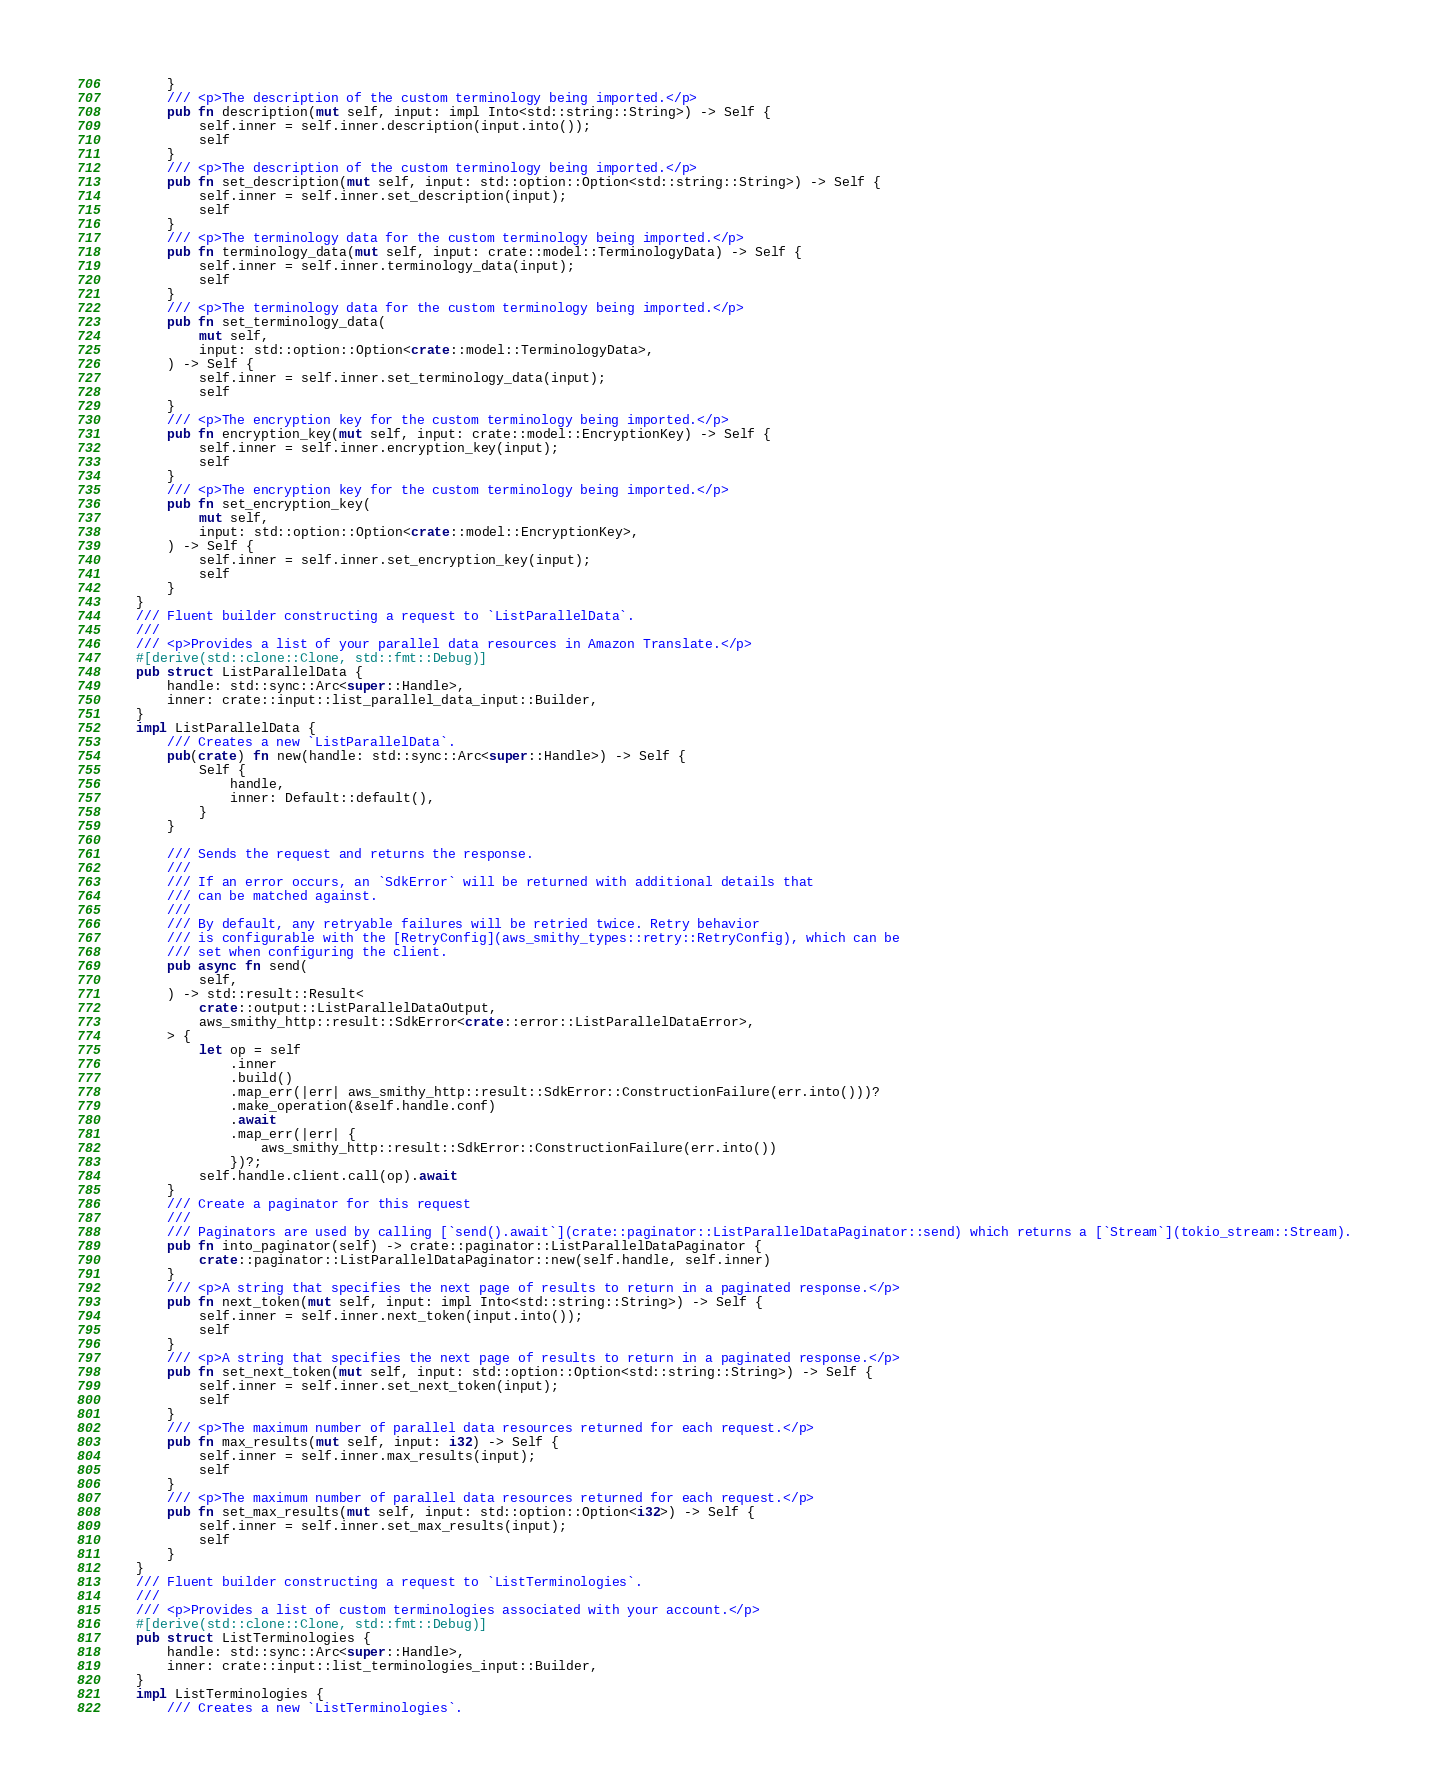Convert code to text. <code><loc_0><loc_0><loc_500><loc_500><_Rust_>        }
        /// <p>The description of the custom terminology being imported.</p>
        pub fn description(mut self, input: impl Into<std::string::String>) -> Self {
            self.inner = self.inner.description(input.into());
            self
        }
        /// <p>The description of the custom terminology being imported.</p>
        pub fn set_description(mut self, input: std::option::Option<std::string::String>) -> Self {
            self.inner = self.inner.set_description(input);
            self
        }
        /// <p>The terminology data for the custom terminology being imported.</p>
        pub fn terminology_data(mut self, input: crate::model::TerminologyData) -> Self {
            self.inner = self.inner.terminology_data(input);
            self
        }
        /// <p>The terminology data for the custom terminology being imported.</p>
        pub fn set_terminology_data(
            mut self,
            input: std::option::Option<crate::model::TerminologyData>,
        ) -> Self {
            self.inner = self.inner.set_terminology_data(input);
            self
        }
        /// <p>The encryption key for the custom terminology being imported.</p>
        pub fn encryption_key(mut self, input: crate::model::EncryptionKey) -> Self {
            self.inner = self.inner.encryption_key(input);
            self
        }
        /// <p>The encryption key for the custom terminology being imported.</p>
        pub fn set_encryption_key(
            mut self,
            input: std::option::Option<crate::model::EncryptionKey>,
        ) -> Self {
            self.inner = self.inner.set_encryption_key(input);
            self
        }
    }
    /// Fluent builder constructing a request to `ListParallelData`.
    ///
    /// <p>Provides a list of your parallel data resources in Amazon Translate.</p>
    #[derive(std::clone::Clone, std::fmt::Debug)]
    pub struct ListParallelData {
        handle: std::sync::Arc<super::Handle>,
        inner: crate::input::list_parallel_data_input::Builder,
    }
    impl ListParallelData {
        /// Creates a new `ListParallelData`.
        pub(crate) fn new(handle: std::sync::Arc<super::Handle>) -> Self {
            Self {
                handle,
                inner: Default::default(),
            }
        }

        /// Sends the request and returns the response.
        ///
        /// If an error occurs, an `SdkError` will be returned with additional details that
        /// can be matched against.
        ///
        /// By default, any retryable failures will be retried twice. Retry behavior
        /// is configurable with the [RetryConfig](aws_smithy_types::retry::RetryConfig), which can be
        /// set when configuring the client.
        pub async fn send(
            self,
        ) -> std::result::Result<
            crate::output::ListParallelDataOutput,
            aws_smithy_http::result::SdkError<crate::error::ListParallelDataError>,
        > {
            let op = self
                .inner
                .build()
                .map_err(|err| aws_smithy_http::result::SdkError::ConstructionFailure(err.into()))?
                .make_operation(&self.handle.conf)
                .await
                .map_err(|err| {
                    aws_smithy_http::result::SdkError::ConstructionFailure(err.into())
                })?;
            self.handle.client.call(op).await
        }
        /// Create a paginator for this request
        ///
        /// Paginators are used by calling [`send().await`](crate::paginator::ListParallelDataPaginator::send) which returns a [`Stream`](tokio_stream::Stream).
        pub fn into_paginator(self) -> crate::paginator::ListParallelDataPaginator {
            crate::paginator::ListParallelDataPaginator::new(self.handle, self.inner)
        }
        /// <p>A string that specifies the next page of results to return in a paginated response.</p>
        pub fn next_token(mut self, input: impl Into<std::string::String>) -> Self {
            self.inner = self.inner.next_token(input.into());
            self
        }
        /// <p>A string that specifies the next page of results to return in a paginated response.</p>
        pub fn set_next_token(mut self, input: std::option::Option<std::string::String>) -> Self {
            self.inner = self.inner.set_next_token(input);
            self
        }
        /// <p>The maximum number of parallel data resources returned for each request.</p>
        pub fn max_results(mut self, input: i32) -> Self {
            self.inner = self.inner.max_results(input);
            self
        }
        /// <p>The maximum number of parallel data resources returned for each request.</p>
        pub fn set_max_results(mut self, input: std::option::Option<i32>) -> Self {
            self.inner = self.inner.set_max_results(input);
            self
        }
    }
    /// Fluent builder constructing a request to `ListTerminologies`.
    ///
    /// <p>Provides a list of custom terminologies associated with your account.</p>
    #[derive(std::clone::Clone, std::fmt::Debug)]
    pub struct ListTerminologies {
        handle: std::sync::Arc<super::Handle>,
        inner: crate::input::list_terminologies_input::Builder,
    }
    impl ListTerminologies {
        /// Creates a new `ListTerminologies`.</code> 